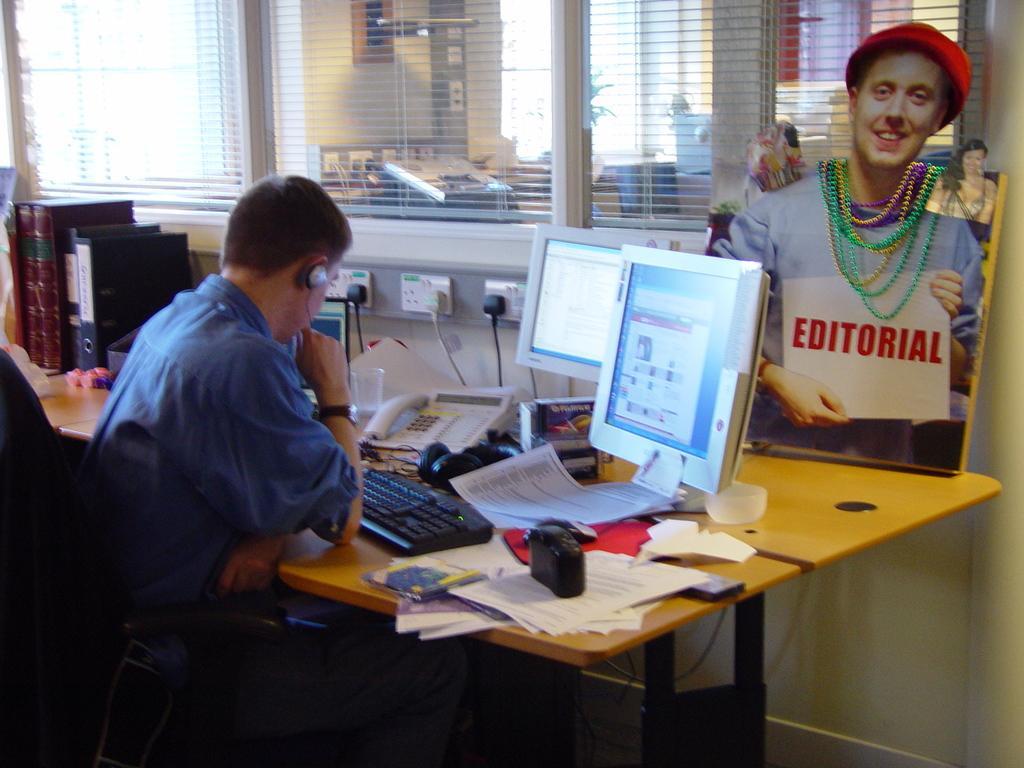Can you describe this image briefly? This Image is clicked in a room where there is a table and a chair. On the table there is a computer, papers, files. There is a window blind on the top. There is a man sitting on the chair. 